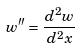Convert formula to latex. <formula><loc_0><loc_0><loc_500><loc_500>w ^ { \prime \prime } = \frac { d ^ { 2 } w } { d ^ { 2 } x }</formula> 